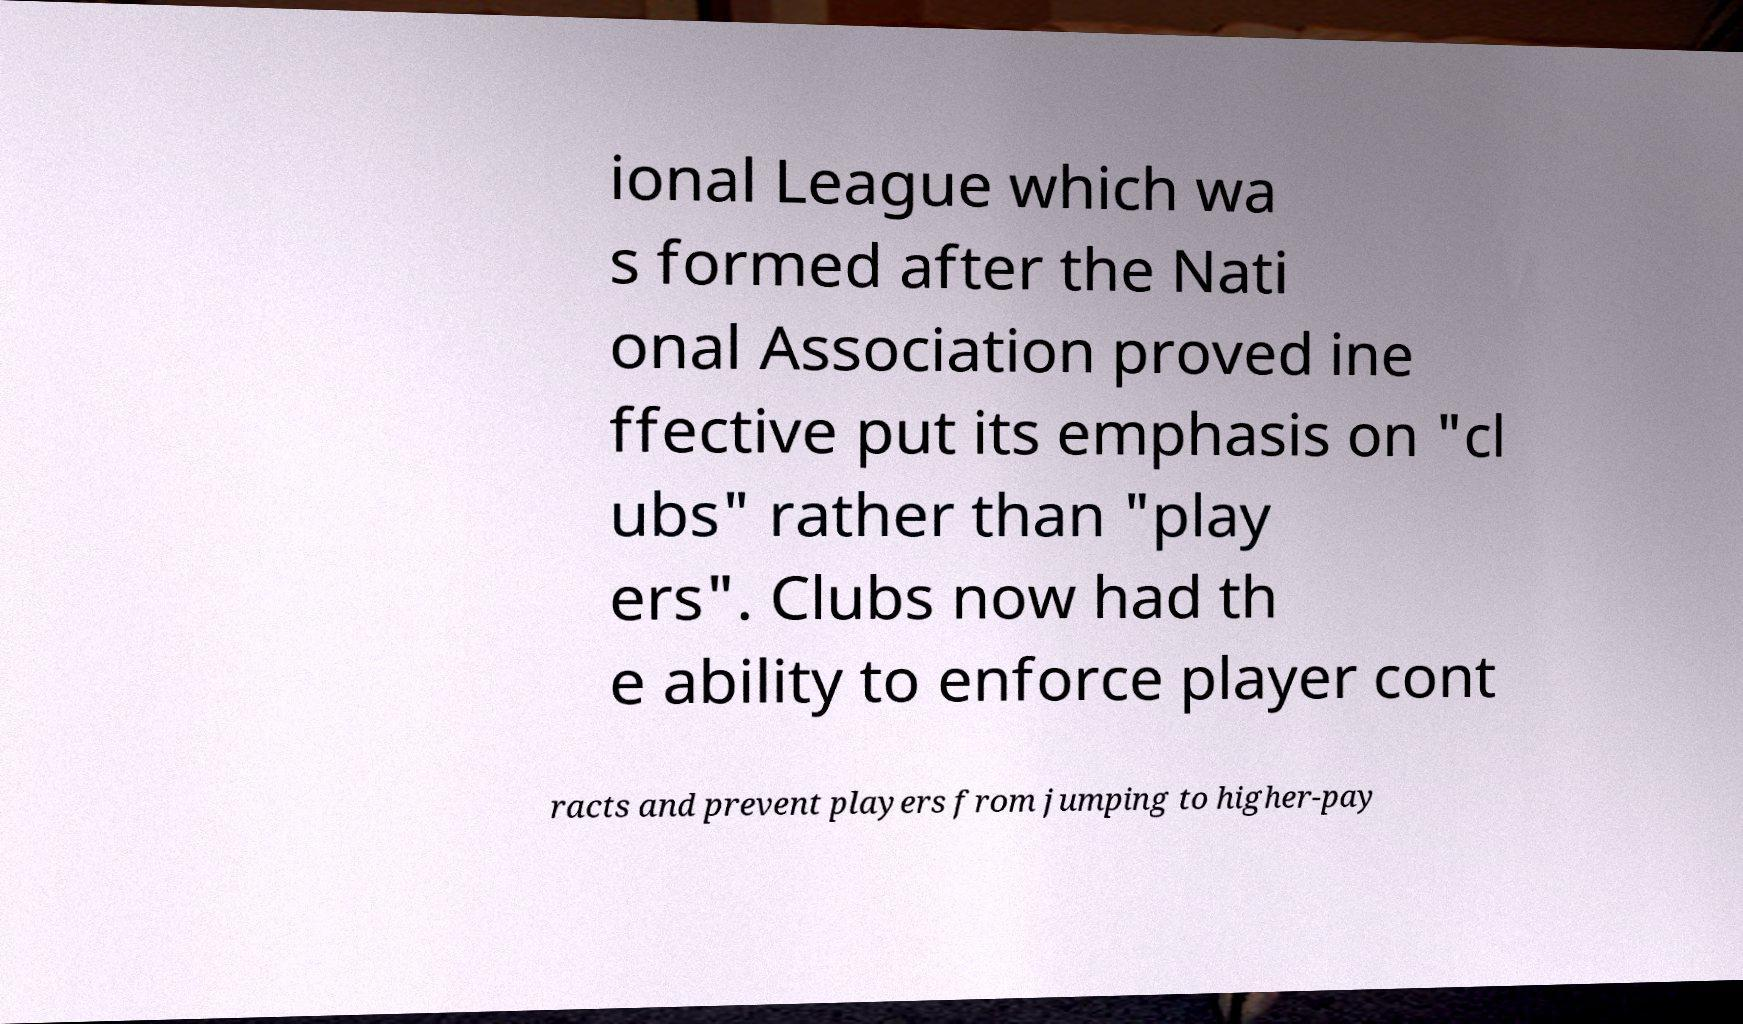Could you extract and type out the text from this image? ional League which wa s formed after the Nati onal Association proved ine ffective put its emphasis on "cl ubs" rather than "play ers". Clubs now had th e ability to enforce player cont racts and prevent players from jumping to higher-pay 